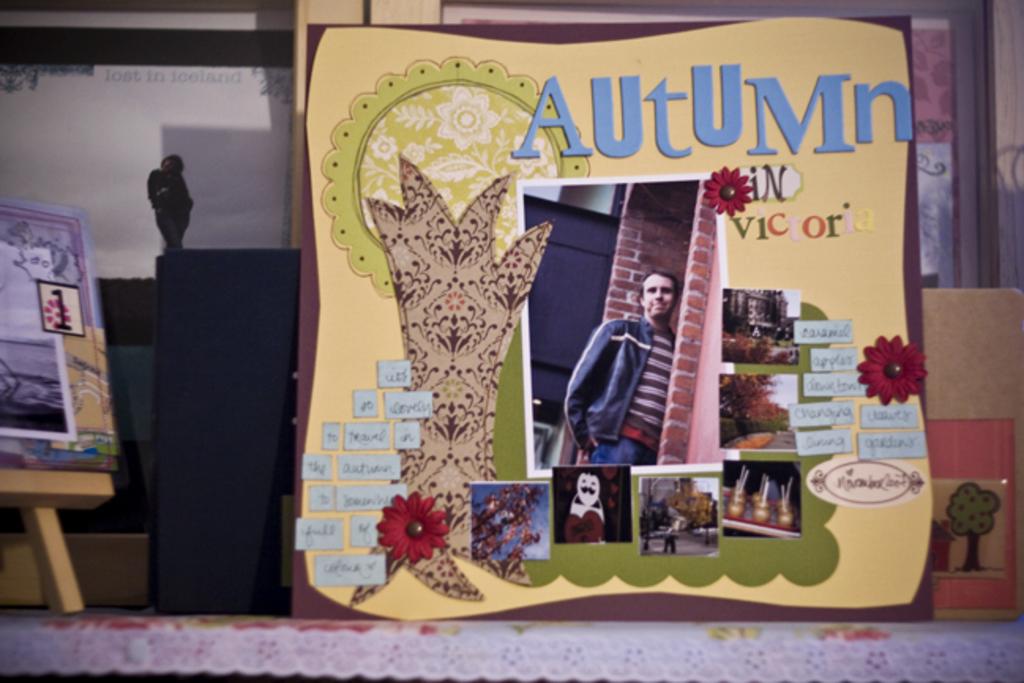Is victoria beautiful in autumn?
Give a very brief answer. Answering does not require reading text in the image. 